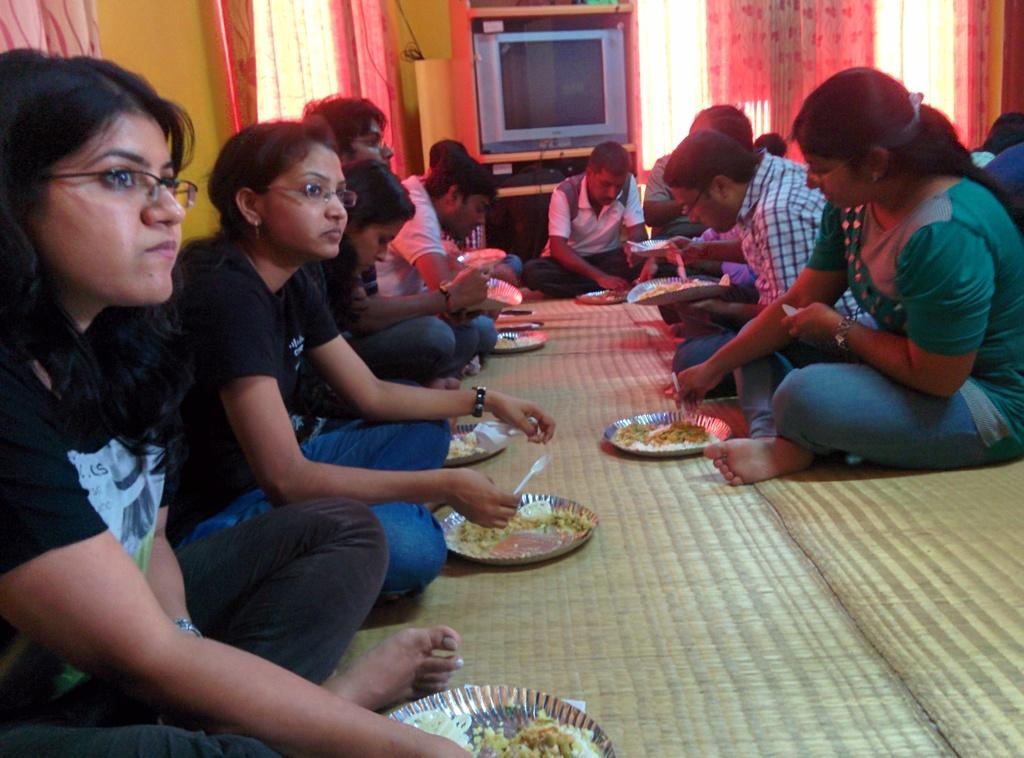What are the people in the image doing? There are people sitting on mats in the image. What can be seen on the plates in the image? There are food items on plates in the image. What utensils are visible in the image? There are spoons in the image. What type of structures can be seen in the image? There are walls in the image. What type of window treatment is present in the image? There are curtains in the image. What electronic device is visible in the image? There is a television in the image. What type of soup is being served in the image? There is no soup present in the image. What is the dinner setting like in the image? The image does not depict a dinner setting; it shows people sitting on mats with food items on plates. 